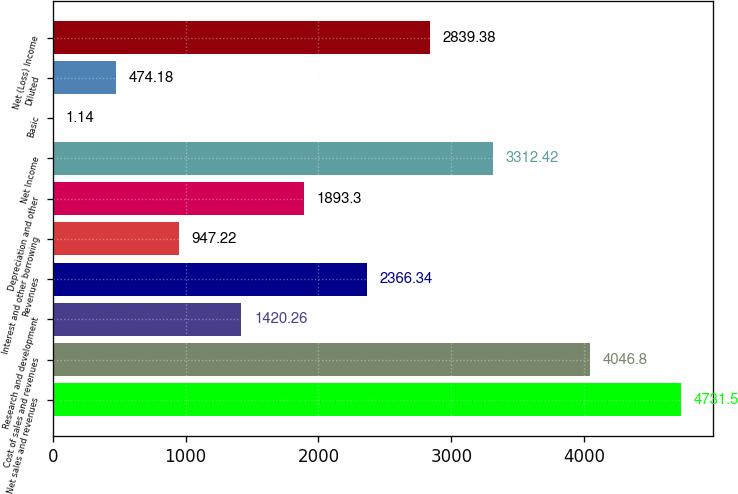Convert chart to OTSL. <chart><loc_0><loc_0><loc_500><loc_500><bar_chart><fcel>Net sales and revenues<fcel>Cost of sales and revenues<fcel>Research and development<fcel>Revenues<fcel>Interest and other borrowing<fcel>Depreciation and other<fcel>Net Income<fcel>Basic<fcel>Diluted<fcel>Net (Loss) Income<nl><fcel>4731.5<fcel>4046.8<fcel>1420.26<fcel>2366.34<fcel>947.22<fcel>1893.3<fcel>3312.42<fcel>1.14<fcel>474.18<fcel>2839.38<nl></chart> 